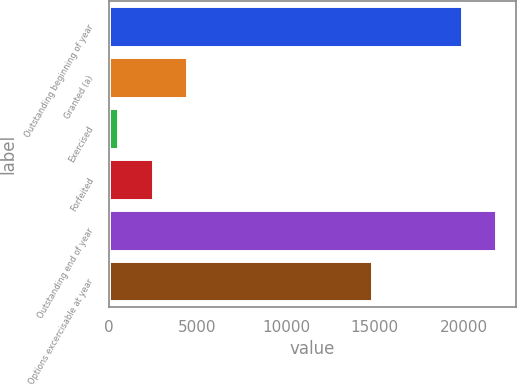<chart> <loc_0><loc_0><loc_500><loc_500><bar_chart><fcel>Outstanding beginning of year<fcel>Granted (a)<fcel>Exercised<fcel>Forfeited<fcel>Outstanding end of year<fcel>Options excercisable at year<nl><fcel>19884<fcel>4434.2<fcel>528<fcel>2481.1<fcel>21837.1<fcel>14857<nl></chart> 